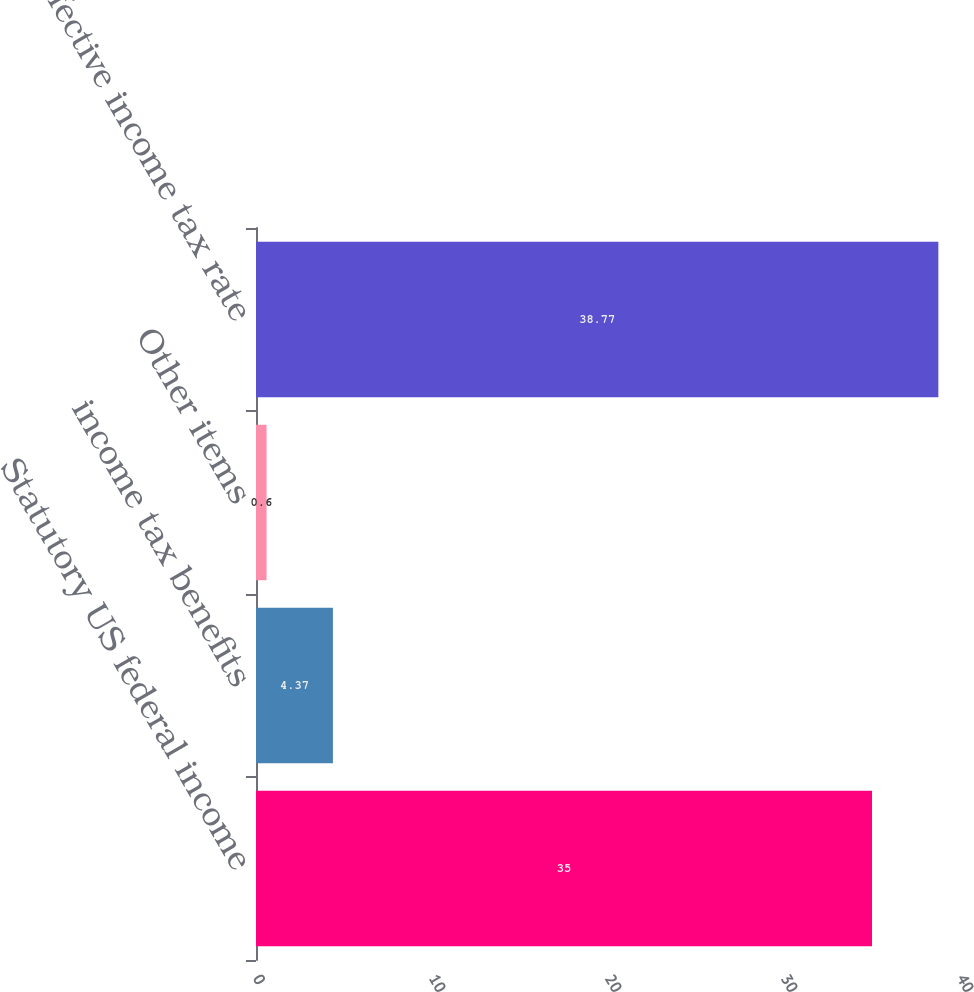Convert chart to OTSL. <chart><loc_0><loc_0><loc_500><loc_500><bar_chart><fcel>Statutory US federal income<fcel>income tax benefits<fcel>Other items<fcel>Effective income tax rate<nl><fcel>35<fcel>4.37<fcel>0.6<fcel>38.77<nl></chart> 